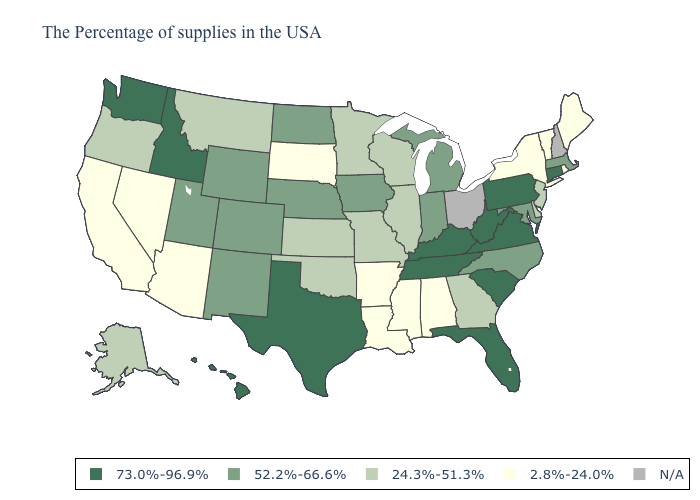What is the lowest value in the USA?
Give a very brief answer. 2.8%-24.0%. What is the value of Massachusetts?
Short answer required. 52.2%-66.6%. Does Wisconsin have the highest value in the MidWest?
Give a very brief answer. No. What is the highest value in the South ?
Answer briefly. 73.0%-96.9%. Which states have the lowest value in the West?
Be succinct. Arizona, Nevada, California. Does the first symbol in the legend represent the smallest category?
Write a very short answer. No. What is the highest value in states that border South Carolina?
Write a very short answer. 52.2%-66.6%. Name the states that have a value in the range 52.2%-66.6%?
Answer briefly. Massachusetts, Maryland, North Carolina, Michigan, Indiana, Iowa, Nebraska, North Dakota, Wyoming, Colorado, New Mexico, Utah. Does Nebraska have the highest value in the USA?
Keep it brief. No. What is the value of Louisiana?
Concise answer only. 2.8%-24.0%. What is the lowest value in states that border New Jersey?
Write a very short answer. 2.8%-24.0%. Name the states that have a value in the range 24.3%-51.3%?
Be succinct. New Jersey, Delaware, Georgia, Wisconsin, Illinois, Missouri, Minnesota, Kansas, Oklahoma, Montana, Oregon, Alaska. 